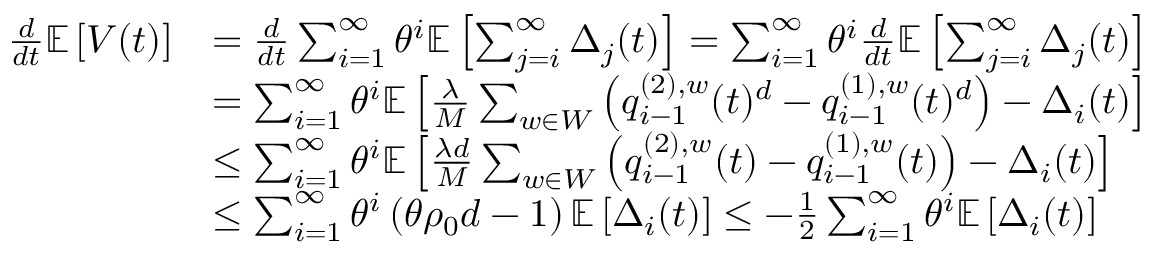Convert formula to latex. <formula><loc_0><loc_0><loc_500><loc_500>\begin{array} { r l } { \frac { d } { d t } \mathbb { E } \left [ V ( t ) \right ] } & { = \frac { d } { d t } \sum _ { i = 1 } ^ { \infty } \theta ^ { i } \mathbb { E } \left [ \sum _ { j = i } ^ { \infty } \Delta _ { j } ( t ) \right ] = \sum _ { i = 1 } ^ { \infty } \theta ^ { i } \frac { d } { d t } \mathbb { E } \left [ \sum _ { j = i } ^ { \infty } \Delta _ { j } ( t ) \right ] } \\ & { = \sum _ { i = 1 } ^ { \infty } \theta ^ { i } \mathbb { E } \left [ \frac { \lambda } { M } \sum _ { w \in W } \left ( q _ { i - 1 } ^ { ( 2 ) , w } ( t ) ^ { d } - q _ { i - 1 } ^ { ( 1 ) , w } ( t ) ^ { d } \right ) - \Delta _ { i } ( t ) \right ] } \\ & { \leq \sum _ { i = 1 } ^ { \infty } \theta ^ { i } \mathbb { E } \left [ \frac { \lambda d } { M } \sum _ { w \in W } \left ( q _ { i - 1 } ^ { ( 2 ) , w } ( t ) - q _ { i - 1 } ^ { ( 1 ) , w } ( t ) \right ) - \Delta _ { i } ( t ) \right ] } \\ & { \leq \sum _ { i = 1 } ^ { \infty } \theta ^ { i } \left ( \theta \rho _ { 0 } d - 1 \right ) \mathbb { E } \left [ \Delta _ { i } ( t ) \right ] \leq - \frac { 1 } { 2 } \sum _ { i = 1 } ^ { \infty } \theta ^ { i } \mathbb { E } \left [ \Delta _ { i } ( t ) \right ] } \end{array}</formula> 